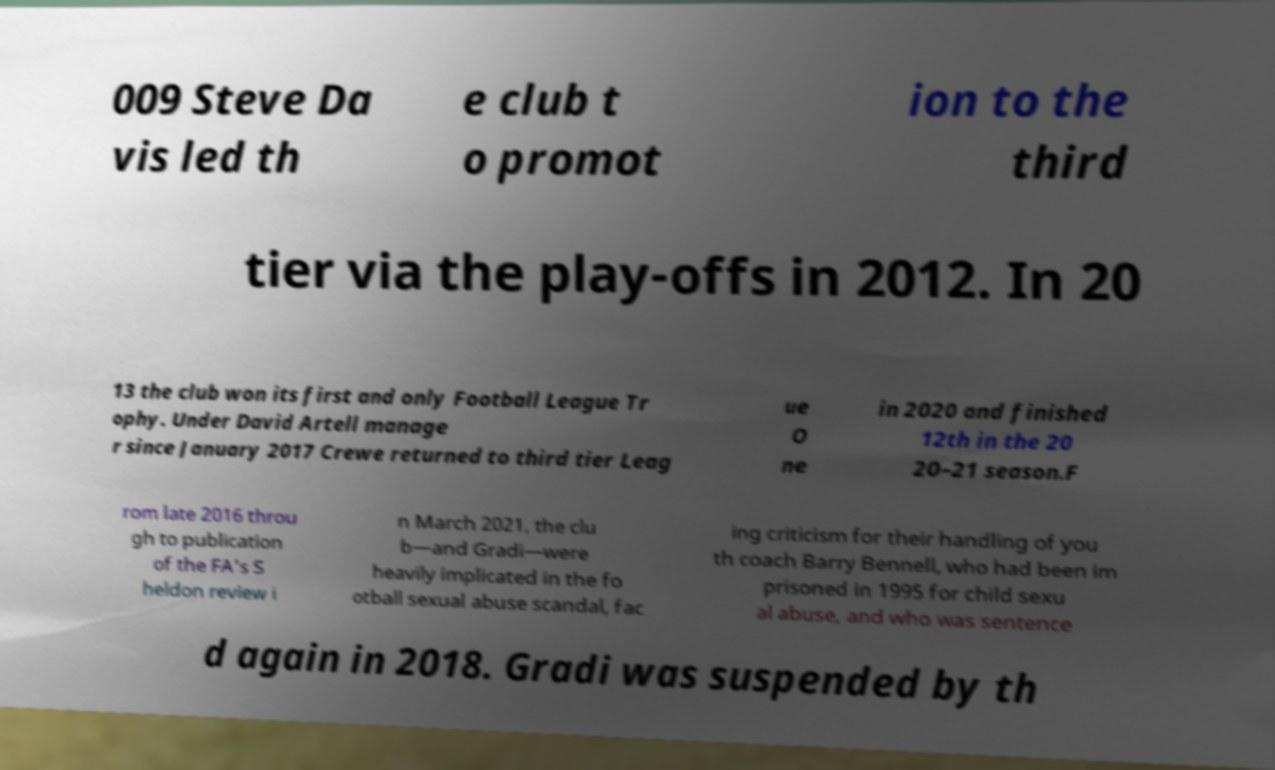Can you read and provide the text displayed in the image?This photo seems to have some interesting text. Can you extract and type it out for me? 009 Steve Da vis led th e club t o promot ion to the third tier via the play-offs in 2012. In 20 13 the club won its first and only Football League Tr ophy. Under David Artell manage r since January 2017 Crewe returned to third tier Leag ue O ne in 2020 and finished 12th in the 20 20–21 season.F rom late 2016 throu gh to publication of the FA's S heldon review i n March 2021, the clu b—and Gradi—were heavily implicated in the fo otball sexual abuse scandal, fac ing criticism for their handling of you th coach Barry Bennell, who had been im prisoned in 1995 for child sexu al abuse, and who was sentence d again in 2018. Gradi was suspended by th 